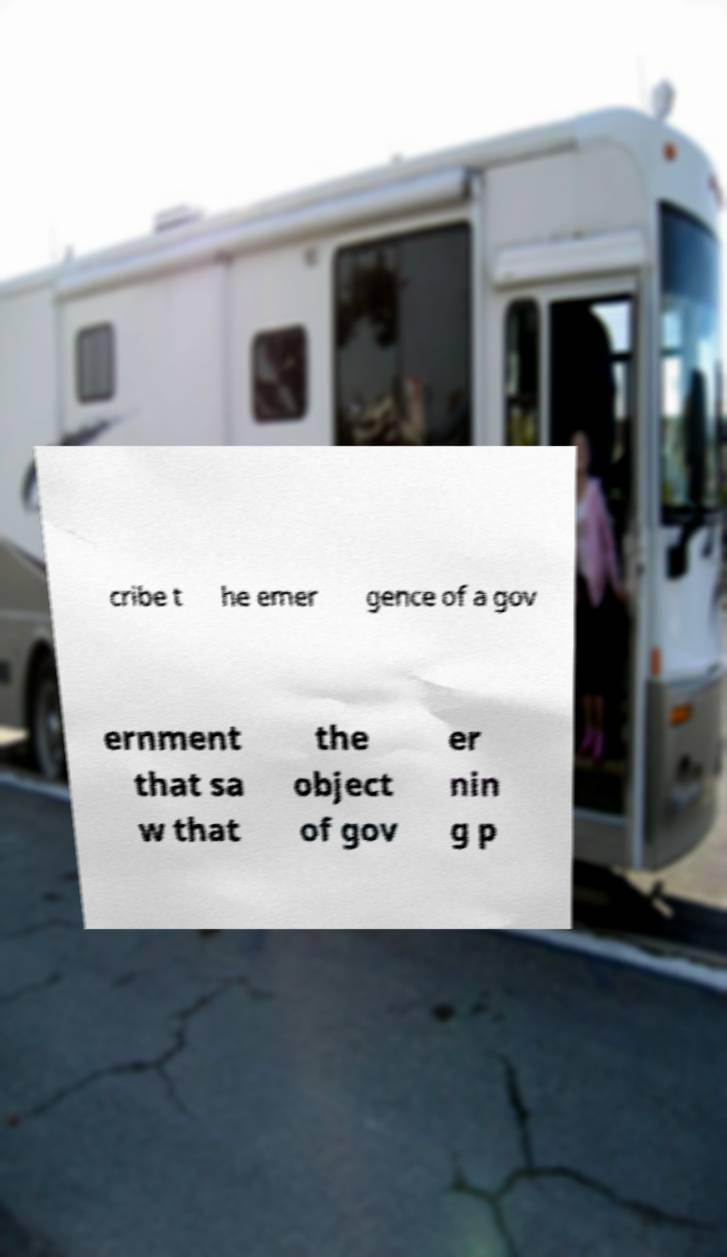Please identify and transcribe the text found in this image. cribe t he emer gence of a gov ernment that sa w that the object of gov er nin g p 